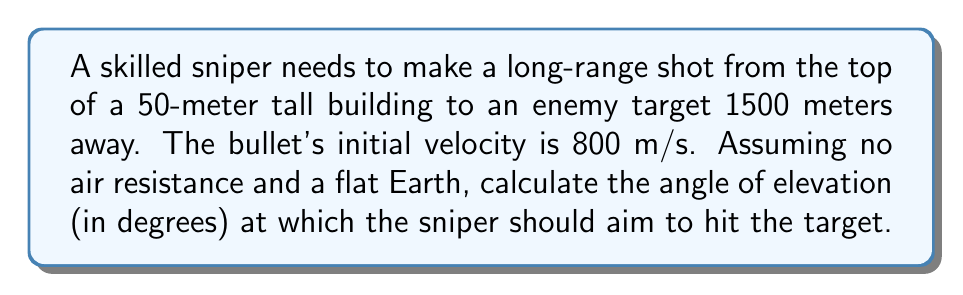Show me your answer to this math problem. To solve this problem, we'll use the equations of motion for projectile motion. Let's break it down step-by-step:

1. Define variables:
   $v_0 = 800$ m/s (initial velocity)
   $x = 1500$ m (horizontal distance)
   $y = -50$ m (vertical distance, negative because the target is below the sniper)
   $g = 9.8$ m/s² (acceleration due to gravity)
   $θ$ = angle of elevation (what we're solving for)

2. Use the equation for the horizontal distance:
   $x = v_0 \cos(θ) \cdot t$

3. Use the equation for vertical displacement:
   $y = v_0 \sin(θ) \cdot t - \frac{1}{2}gt^2$

4. Solve the first equation for time $t$:
   $t = \frac{x}{v_0 \cos(θ)}$

5. Substitute this into the second equation:
   $y = v_0 \sin(θ) \cdot \frac{x}{v_0 \cos(θ)} - \frac{1}{2}g\left(\frac{x}{v_0 \cos(θ)}\right)^2$

6. Simplify:
   $y = x \tan(θ) - \frac{gx^2}{2v_0^2 \cos^2(θ)}$

7. Substitute known values:
   $-50 = 1500 \tan(θ) - \frac{9.8 \cdot 1500^2}{2 \cdot 800^2 \cos^2(θ)}$

8. Rearrange:
   $1500 \tan(θ) - \frac{10293750}{cos^2(θ)} = -50$

9. This equation can be solved numerically. Using a calculator or computer program, we find:
   $θ ≈ 0.0339$ radians

10. Convert to degrees:
    $θ ≈ 0.0339 \cdot \frac{180}{π} ≈ 1.94°$
Answer: $1.94°$ 